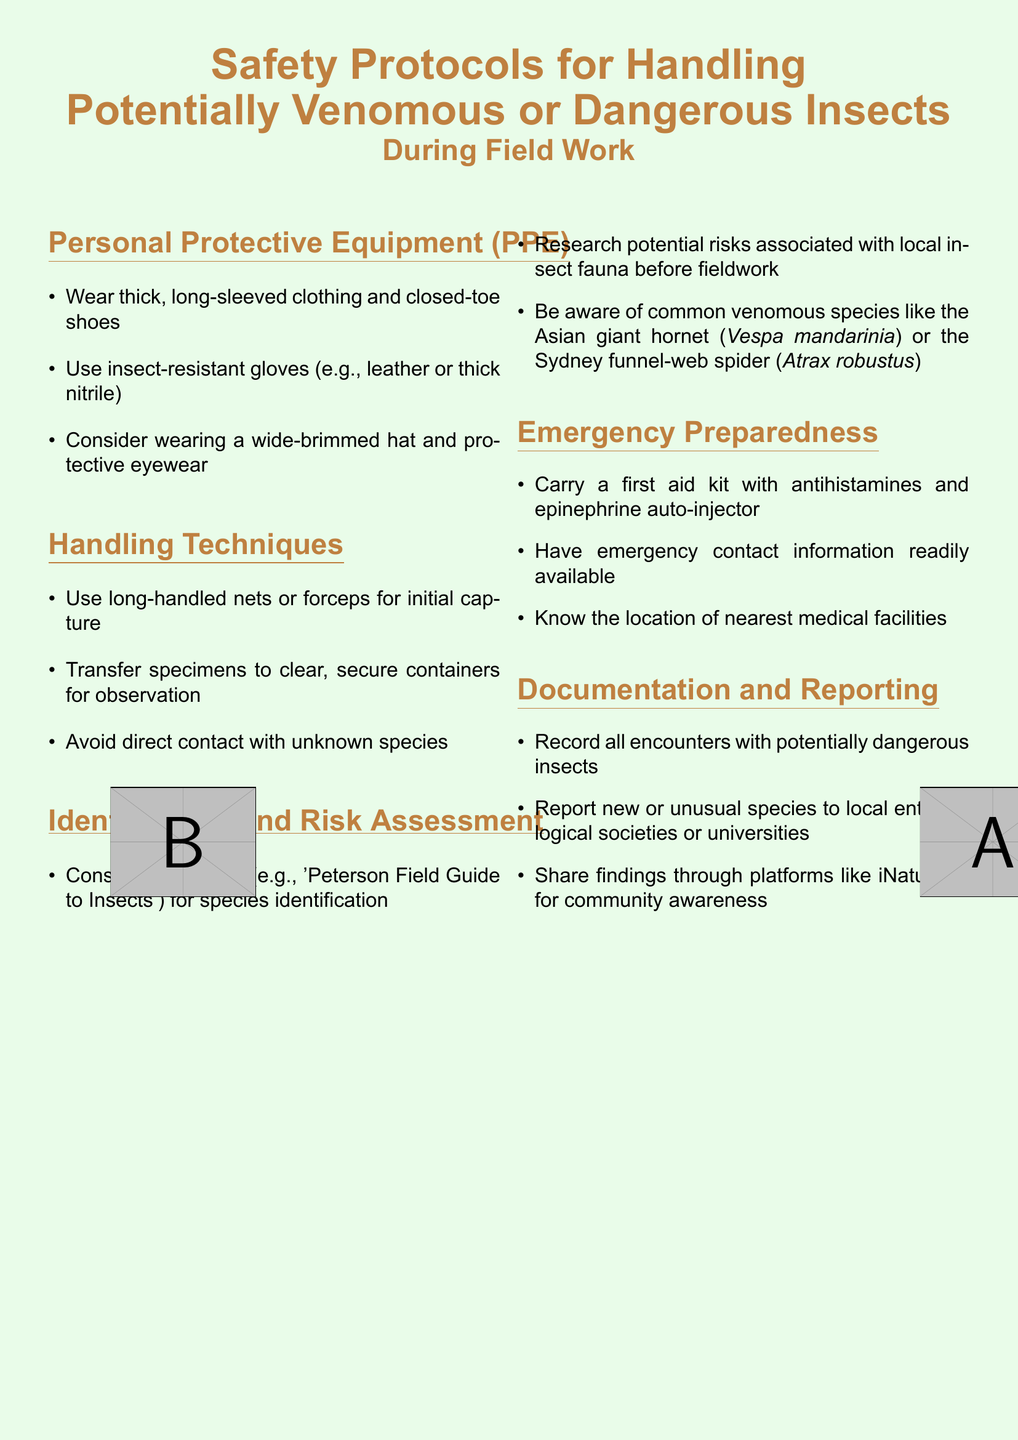What should be worn for protection during fieldwork? The document specifies wearing thick, long-sleeved clothing and closed-toe shoes as personal protective equipment.
Answer: Thick, long-sleeved clothing and closed-toe shoes What type of gloves is recommended? It suggests using insect-resistant gloves made of leather or thick nitrile for personal protection.
Answer: Insect-resistant gloves (e.g., leather or thick nitrile) What method should be used for initial capture of insects? The document advises using long-handled nets or forceps for capturing potentially dangerous insects.
Answer: Long-handled nets or forceps Which species are mentioned as commonly venomous? The document lists the Asian giant hornet and the Sydney funnel-web spider as examples of common venomous species.
Answer: Asian giant hornet or Sydney funnel-web spider What should be included in the first aid kit? It specifies carrying a first aid kit with antihistamines and an epinephrine auto-injector for emergencies.
Answer: Antihistamines and epinephrine auto-injector How should encounters with dangerous insects be handled? The document recommends recording all encounters with potentially dangerous insects as part of the documentation process.
Answer: Record all encounters What is one platform suggested for sharing findings? It states that findings can be shared through platforms like iNaturalist to promote community awareness.
Answer: iNaturalist Why is it important to consult field guides? Consulting field guides is crucial for species identification and understanding risks associated with local insect fauna.
Answer: Species identification and risk understanding What is the main focus of this document? The document focuses on safety protocols for handling potentially venomous or dangerous insects during field work.
Answer: Safety protocols for handling potentially venomous or dangerous insects 